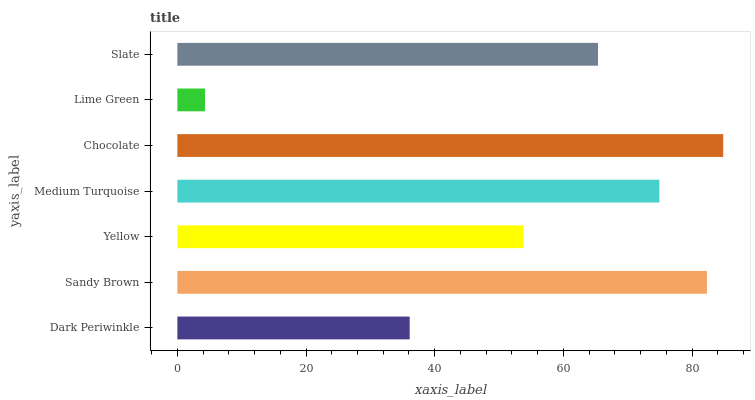Is Lime Green the minimum?
Answer yes or no. Yes. Is Chocolate the maximum?
Answer yes or no. Yes. Is Sandy Brown the minimum?
Answer yes or no. No. Is Sandy Brown the maximum?
Answer yes or no. No. Is Sandy Brown greater than Dark Periwinkle?
Answer yes or no. Yes. Is Dark Periwinkle less than Sandy Brown?
Answer yes or no. Yes. Is Dark Periwinkle greater than Sandy Brown?
Answer yes or no. No. Is Sandy Brown less than Dark Periwinkle?
Answer yes or no. No. Is Slate the high median?
Answer yes or no. Yes. Is Slate the low median?
Answer yes or no. Yes. Is Lime Green the high median?
Answer yes or no. No. Is Lime Green the low median?
Answer yes or no. No. 